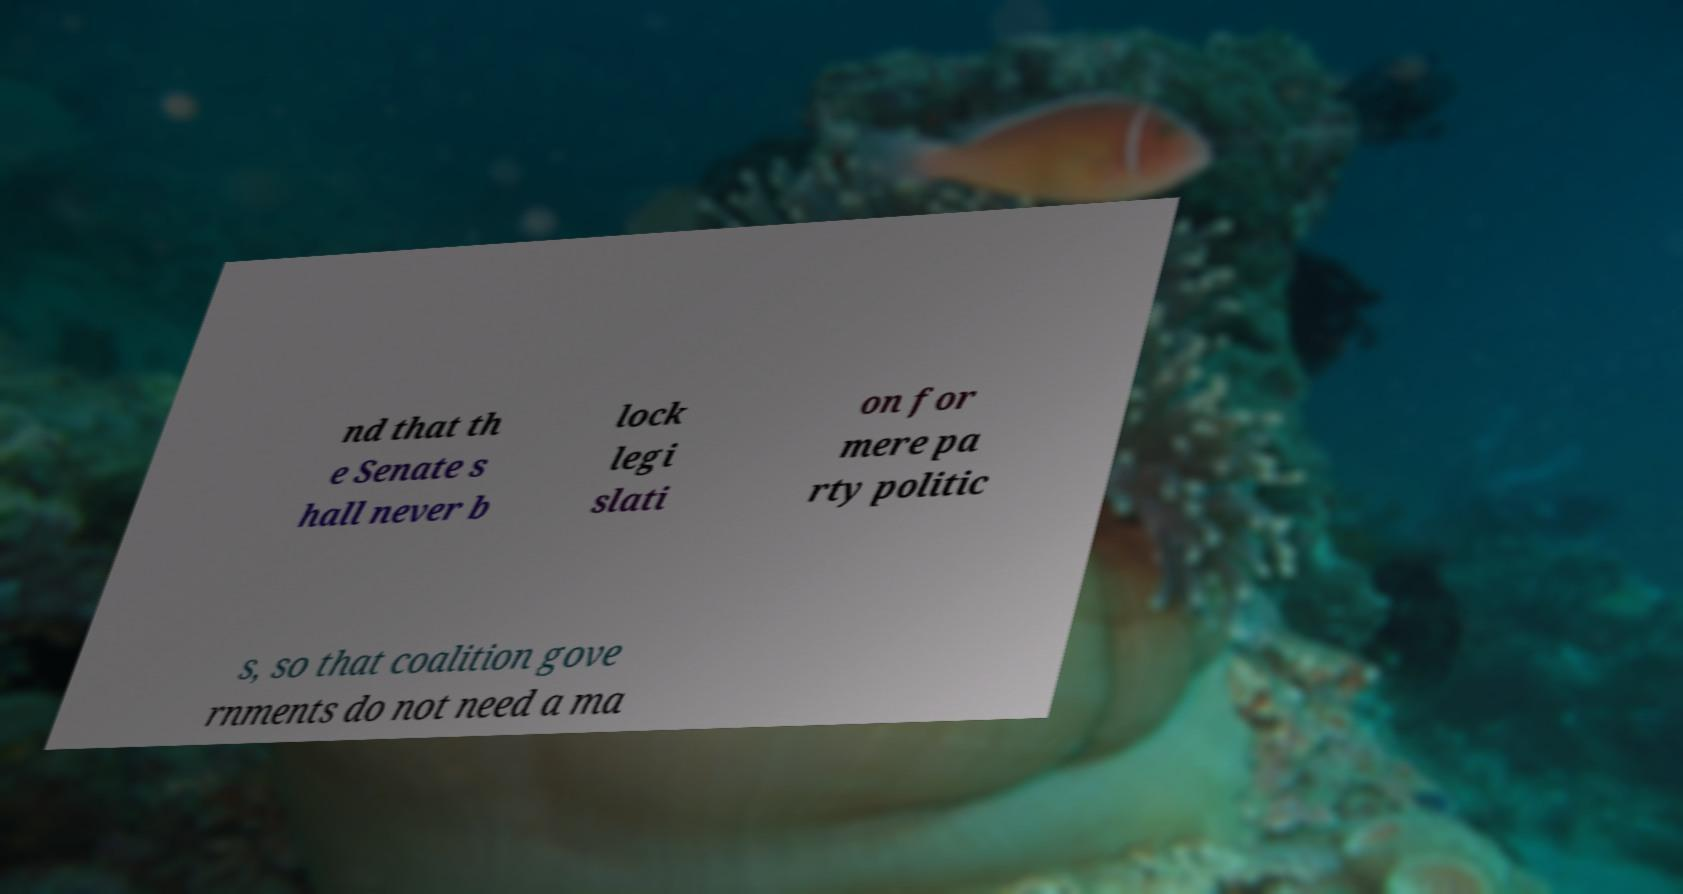Please read and relay the text visible in this image. What does it say? nd that th e Senate s hall never b lock legi slati on for mere pa rty politic s, so that coalition gove rnments do not need a ma 